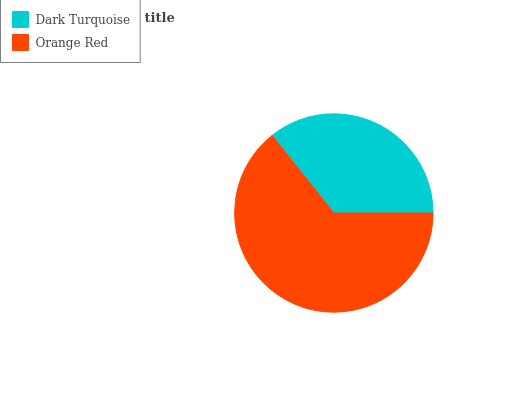Is Dark Turquoise the minimum?
Answer yes or no. Yes. Is Orange Red the maximum?
Answer yes or no. Yes. Is Orange Red the minimum?
Answer yes or no. No. Is Orange Red greater than Dark Turquoise?
Answer yes or no. Yes. Is Dark Turquoise less than Orange Red?
Answer yes or no. Yes. Is Dark Turquoise greater than Orange Red?
Answer yes or no. No. Is Orange Red less than Dark Turquoise?
Answer yes or no. No. Is Orange Red the high median?
Answer yes or no. Yes. Is Dark Turquoise the low median?
Answer yes or no. Yes. Is Dark Turquoise the high median?
Answer yes or no. No. Is Orange Red the low median?
Answer yes or no. No. 